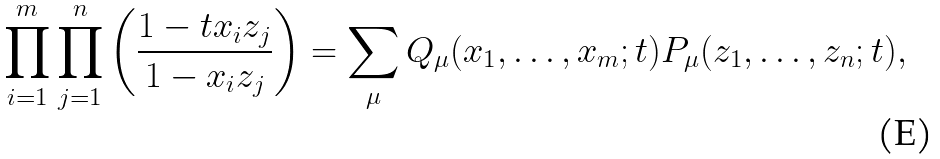<formula> <loc_0><loc_0><loc_500><loc_500>\prod _ { i = 1 } ^ { m } \prod _ { j = 1 } ^ { n } \left ( \frac { 1 - t x _ { i } z _ { j } } { 1 - x _ { i } z _ { j } } \right ) = \sum _ { \mu } Q _ { \mu } ( x _ { 1 } , \dots , x _ { m } ; t ) P _ { \mu } ( z _ { 1 } , \dots , z _ { n } ; t ) ,</formula> 